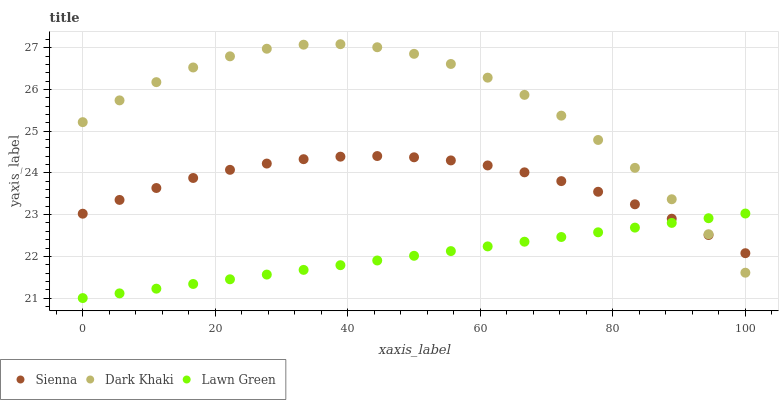Does Lawn Green have the minimum area under the curve?
Answer yes or no. Yes. Does Dark Khaki have the maximum area under the curve?
Answer yes or no. Yes. Does Dark Khaki have the minimum area under the curve?
Answer yes or no. No. Does Lawn Green have the maximum area under the curve?
Answer yes or no. No. Is Lawn Green the smoothest?
Answer yes or no. Yes. Is Dark Khaki the roughest?
Answer yes or no. Yes. Is Dark Khaki the smoothest?
Answer yes or no. No. Is Lawn Green the roughest?
Answer yes or no. No. Does Lawn Green have the lowest value?
Answer yes or no. Yes. Does Dark Khaki have the lowest value?
Answer yes or no. No. Does Dark Khaki have the highest value?
Answer yes or no. Yes. Does Lawn Green have the highest value?
Answer yes or no. No. Does Sienna intersect Dark Khaki?
Answer yes or no. Yes. Is Sienna less than Dark Khaki?
Answer yes or no. No. Is Sienna greater than Dark Khaki?
Answer yes or no. No. 